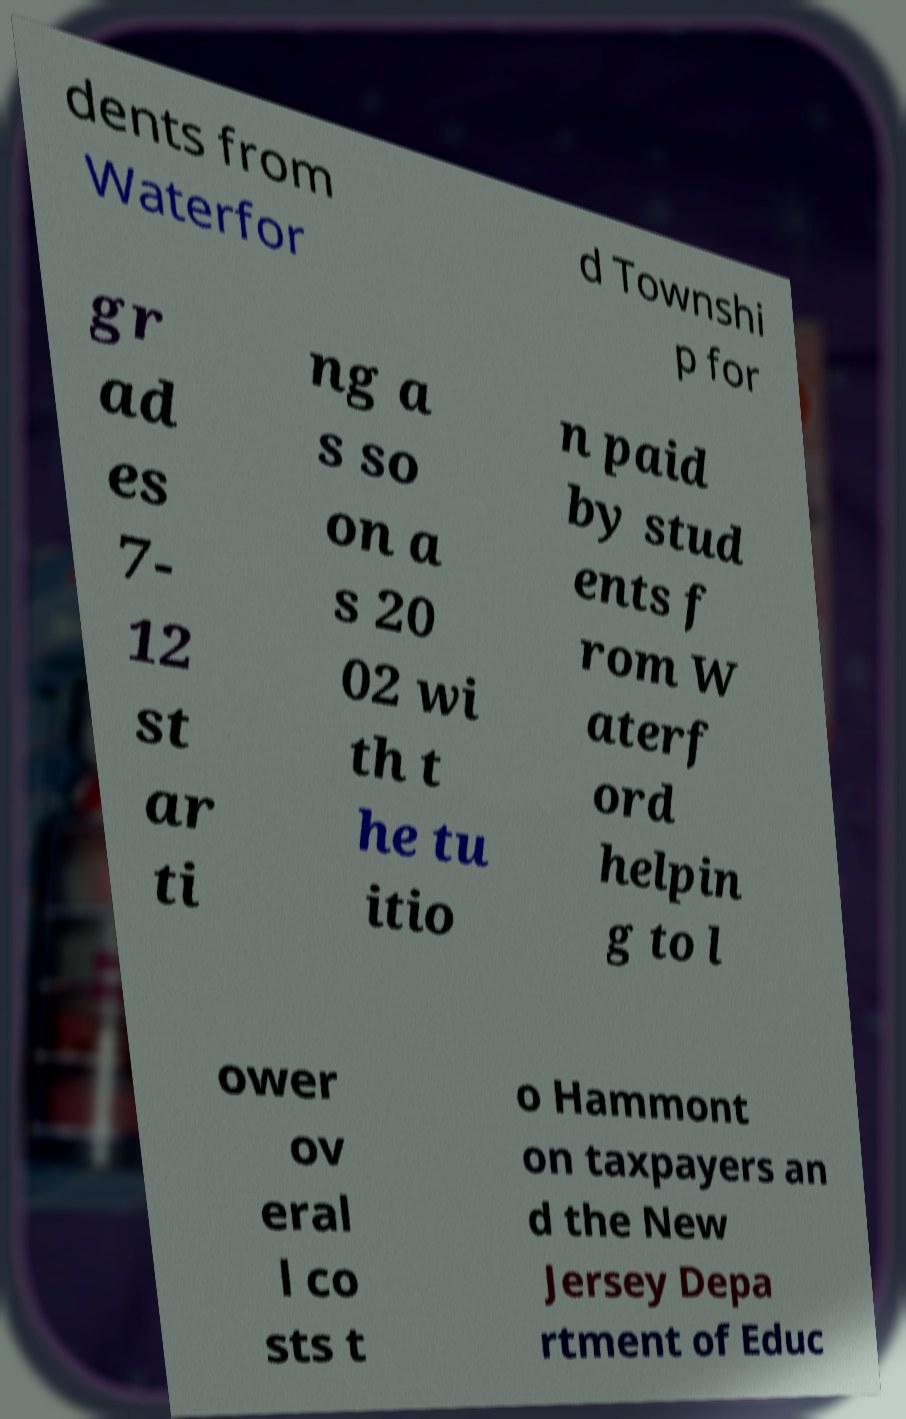Can you read and provide the text displayed in the image?This photo seems to have some interesting text. Can you extract and type it out for me? dents from Waterfor d Townshi p for gr ad es 7- 12 st ar ti ng a s so on a s 20 02 wi th t he tu itio n paid by stud ents f rom W aterf ord helpin g to l ower ov eral l co sts t o Hammont on taxpayers an d the New Jersey Depa rtment of Educ 